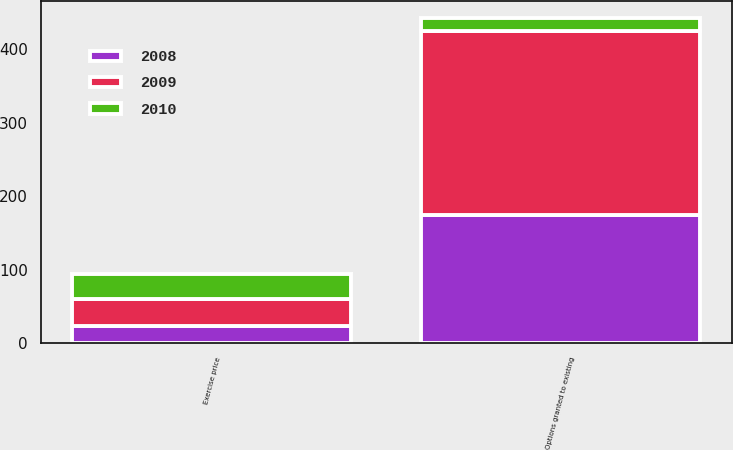Convert chart to OTSL. <chart><loc_0><loc_0><loc_500><loc_500><stacked_bar_chart><ecel><fcel>Options granted to existing<fcel>Exercise price<nl><fcel>2010<fcel>18<fcel>33.82<nl><fcel>2008<fcel>175<fcel>23.28<nl><fcel>2009<fcel>250<fcel>37.09<nl></chart> 